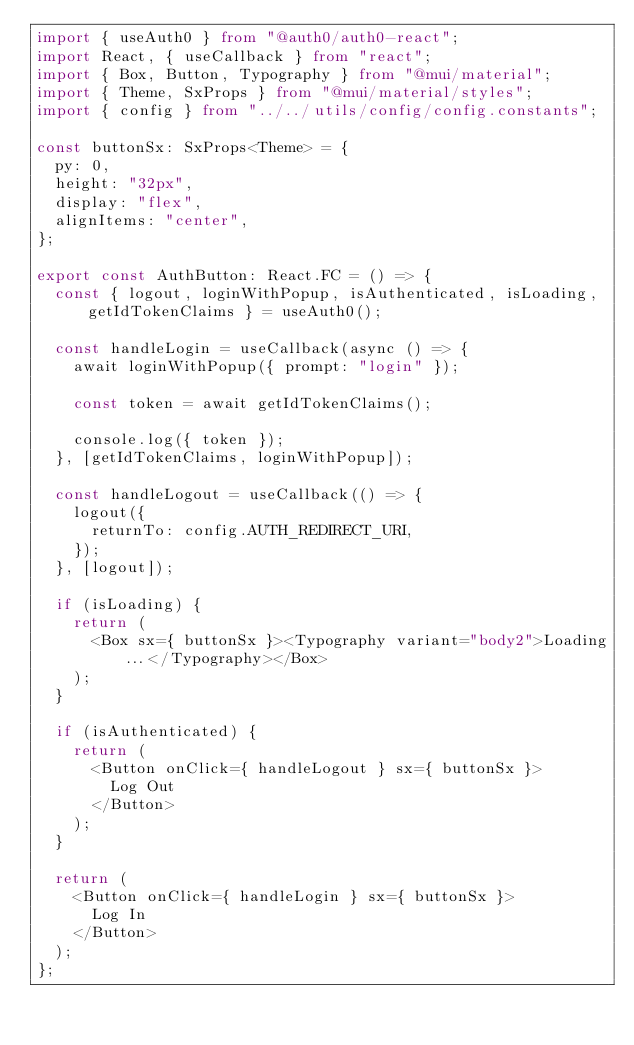<code> <loc_0><loc_0><loc_500><loc_500><_TypeScript_>import { useAuth0 } from "@auth0/auth0-react";
import React, { useCallback } from "react";
import { Box, Button, Typography } from "@mui/material";
import { Theme, SxProps } from "@mui/material/styles";
import { config } from "../../utils/config/config.constants";

const buttonSx: SxProps<Theme> = {
  py: 0,
  height: "32px",
  display: "flex",
  alignItems: "center",
};

export const AuthButton: React.FC = () => {
  const { logout, loginWithPopup, isAuthenticated, isLoading, getIdTokenClaims } = useAuth0();

  const handleLogin = useCallback(async () => {
    await loginWithPopup({ prompt: "login" });

    const token = await getIdTokenClaims();

    console.log({ token });
  }, [getIdTokenClaims, loginWithPopup]);

  const handleLogout = useCallback(() => {
    logout({
      returnTo: config.AUTH_REDIRECT_URI,
    });
  }, [logout]);

  if (isLoading) {
    return (
      <Box sx={ buttonSx }><Typography variant="body2">Loading...</Typography></Box>
    );
  }

  if (isAuthenticated) {
    return (
      <Button onClick={ handleLogout } sx={ buttonSx }>
        Log Out
      </Button>
    );
  }

  return (
    <Button onClick={ handleLogin } sx={ buttonSx }>
      Log In
    </Button>
  );
};
</code> 